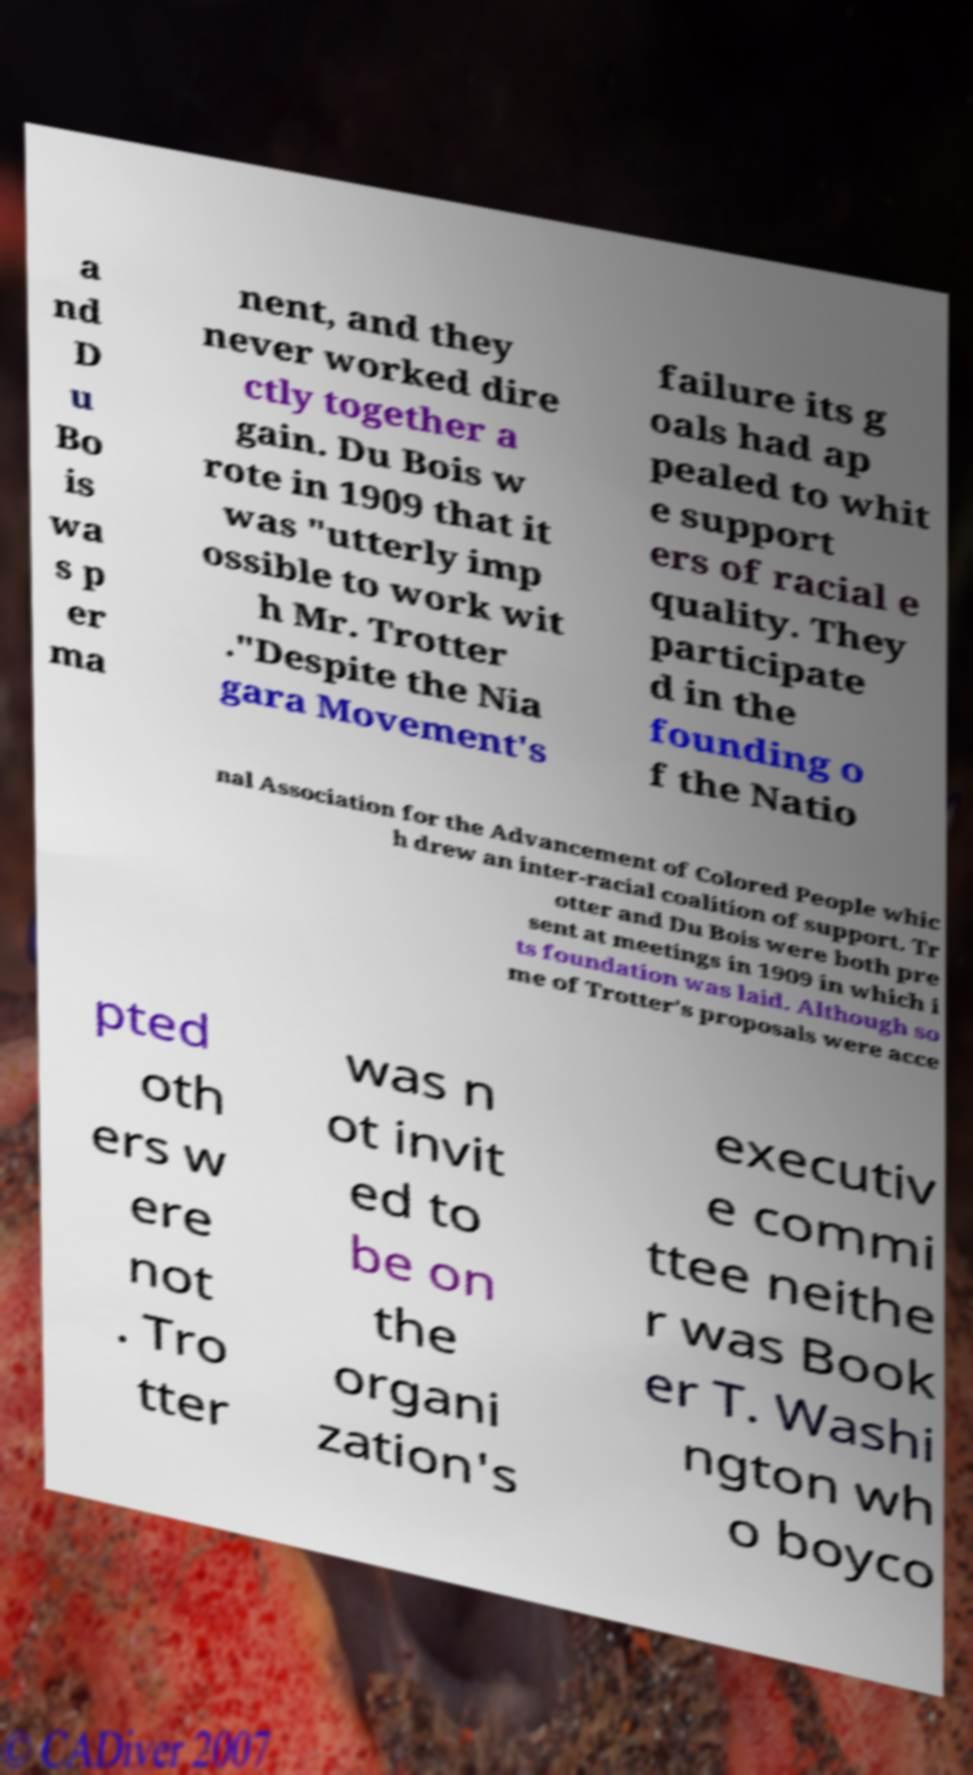I need the written content from this picture converted into text. Can you do that? a nd D u Bo is wa s p er ma nent, and they never worked dire ctly together a gain. Du Bois w rote in 1909 that it was "utterly imp ossible to work wit h Mr. Trotter ."Despite the Nia gara Movement's failure its g oals had ap pealed to whit e support ers of racial e quality. They participate d in the founding o f the Natio nal Association for the Advancement of Colored People whic h drew an inter-racial coalition of support. Tr otter and Du Bois were both pre sent at meetings in 1909 in which i ts foundation was laid. Although so me of Trotter's proposals were acce pted oth ers w ere not . Tro tter was n ot invit ed to be on the organi zation's executiv e commi ttee neithe r was Book er T. Washi ngton wh o boyco 